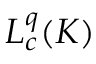Convert formula to latex. <formula><loc_0><loc_0><loc_500><loc_500>L _ { c } ^ { q } ( K )</formula> 